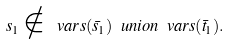Convert formula to latex. <formula><loc_0><loc_0><loc_500><loc_500>s _ { 1 } \notin \ v a r s ( \bar { s } _ { 1 } ) \ u n i o n \ v a r s ( \bar { t } _ { 1 } ) .</formula> 